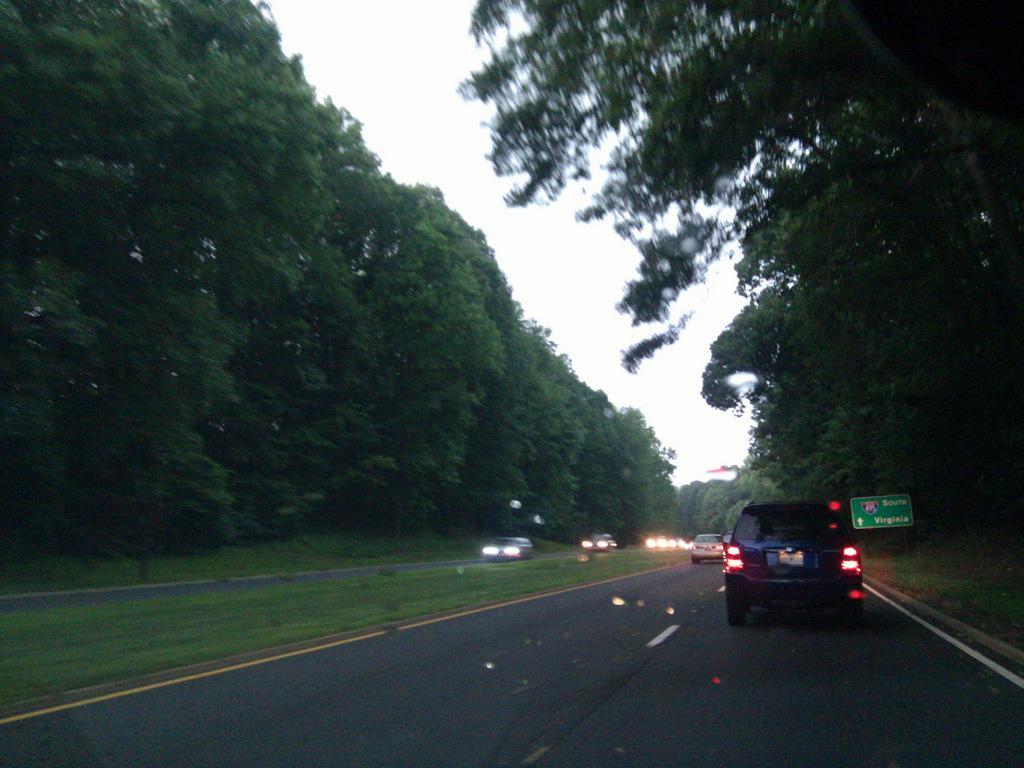Could you give a brief overview of what you see in this image? In the foreground of this image, there are vehicles moving on the road to which trees are either side to it. On the top, there is the sky. 